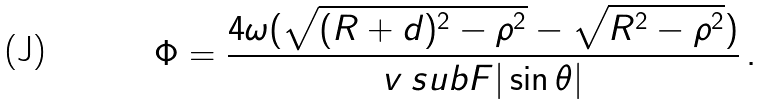Convert formula to latex. <formula><loc_0><loc_0><loc_500><loc_500>\Phi = \frac { 4 \omega ( \sqrt { ( R + d ) ^ { 2 } - \rho ^ { 2 } } - \sqrt { R ^ { 2 } - \rho ^ { 2 } } ) } { v _ { \ } s u b F | \sin { \theta } | } \, .</formula> 